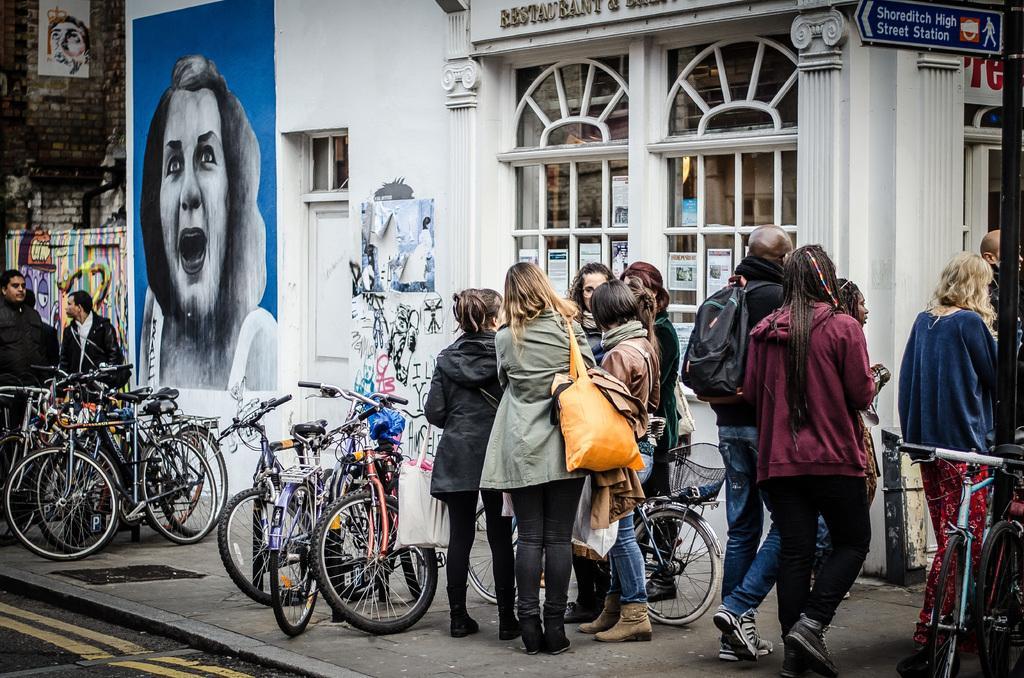How would you summarize this image in a sentence or two? In this image there are people standing on a footpath and there are cycles, in the background there is a building. 